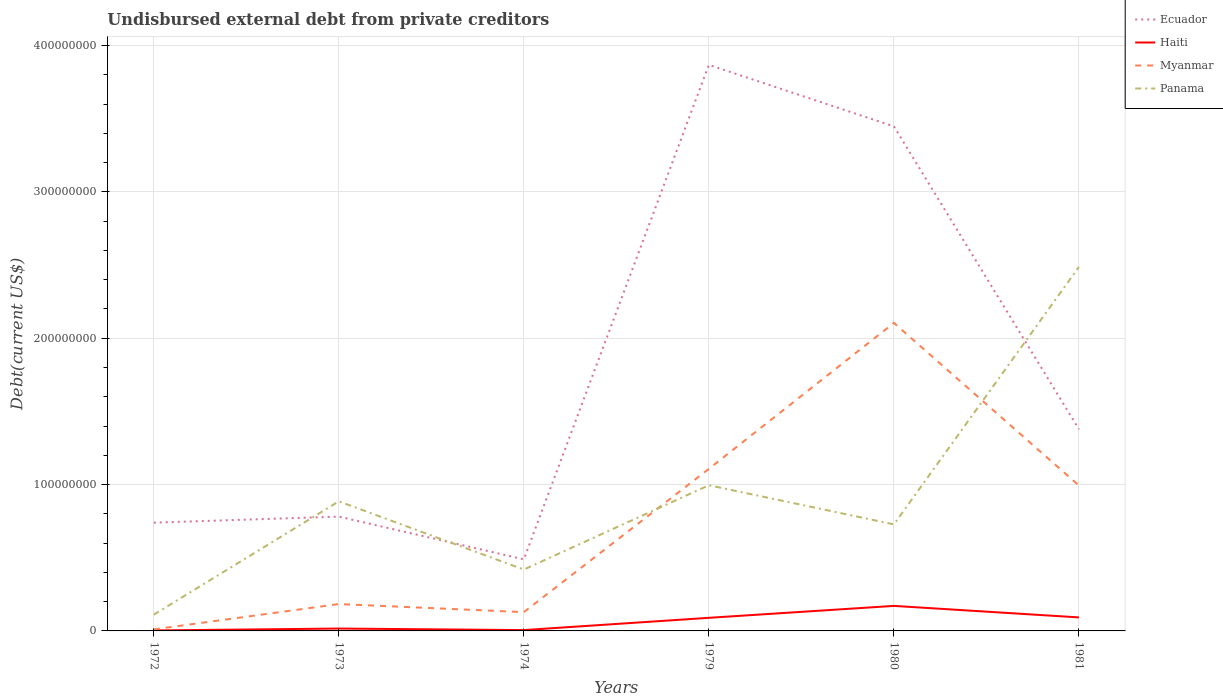How many different coloured lines are there?
Your response must be concise. 4. Across all years, what is the maximum total debt in Myanmar?
Ensure brevity in your answer.  1.05e+06. What is the total total debt in Panama in the graph?
Your response must be concise. -6.17e+07. What is the difference between the highest and the second highest total debt in Myanmar?
Ensure brevity in your answer.  2.09e+08. How many lines are there?
Your response must be concise. 4. How many years are there in the graph?
Ensure brevity in your answer.  6. Are the values on the major ticks of Y-axis written in scientific E-notation?
Keep it short and to the point. No. Does the graph contain grids?
Ensure brevity in your answer.  Yes. Where does the legend appear in the graph?
Provide a succinct answer. Top right. How are the legend labels stacked?
Provide a succinct answer. Vertical. What is the title of the graph?
Offer a very short reply. Undisbursed external debt from private creditors. What is the label or title of the Y-axis?
Make the answer very short. Debt(current US$). What is the Debt(current US$) of Ecuador in 1972?
Keep it short and to the point. 7.40e+07. What is the Debt(current US$) of Haiti in 1972?
Ensure brevity in your answer.  3.25e+05. What is the Debt(current US$) in Myanmar in 1972?
Offer a terse response. 1.05e+06. What is the Debt(current US$) of Panama in 1972?
Give a very brief answer. 1.11e+07. What is the Debt(current US$) of Ecuador in 1973?
Offer a very short reply. 7.81e+07. What is the Debt(current US$) in Haiti in 1973?
Keep it short and to the point. 1.62e+06. What is the Debt(current US$) of Myanmar in 1973?
Your answer should be very brief. 1.84e+07. What is the Debt(current US$) in Panama in 1973?
Give a very brief answer. 8.85e+07. What is the Debt(current US$) in Ecuador in 1974?
Give a very brief answer. 4.89e+07. What is the Debt(current US$) in Haiti in 1974?
Your response must be concise. 5.69e+05. What is the Debt(current US$) of Myanmar in 1974?
Your answer should be compact. 1.28e+07. What is the Debt(current US$) of Panama in 1974?
Your answer should be compact. 4.19e+07. What is the Debt(current US$) of Ecuador in 1979?
Make the answer very short. 3.87e+08. What is the Debt(current US$) in Haiti in 1979?
Your answer should be compact. 8.96e+06. What is the Debt(current US$) of Myanmar in 1979?
Make the answer very short. 1.11e+08. What is the Debt(current US$) of Panama in 1979?
Ensure brevity in your answer.  9.95e+07. What is the Debt(current US$) in Ecuador in 1980?
Provide a short and direct response. 3.45e+08. What is the Debt(current US$) in Haiti in 1980?
Ensure brevity in your answer.  1.71e+07. What is the Debt(current US$) of Myanmar in 1980?
Your answer should be compact. 2.10e+08. What is the Debt(current US$) in Panama in 1980?
Your response must be concise. 7.28e+07. What is the Debt(current US$) in Ecuador in 1981?
Offer a very short reply. 1.38e+08. What is the Debt(current US$) in Haiti in 1981?
Provide a short and direct response. 9.24e+06. What is the Debt(current US$) of Myanmar in 1981?
Your answer should be very brief. 9.93e+07. What is the Debt(current US$) of Panama in 1981?
Your answer should be compact. 2.49e+08. Across all years, what is the maximum Debt(current US$) of Ecuador?
Your response must be concise. 3.87e+08. Across all years, what is the maximum Debt(current US$) in Haiti?
Offer a terse response. 1.71e+07. Across all years, what is the maximum Debt(current US$) of Myanmar?
Provide a succinct answer. 2.10e+08. Across all years, what is the maximum Debt(current US$) in Panama?
Your answer should be very brief. 2.49e+08. Across all years, what is the minimum Debt(current US$) of Ecuador?
Ensure brevity in your answer.  4.89e+07. Across all years, what is the minimum Debt(current US$) in Haiti?
Offer a terse response. 3.25e+05. Across all years, what is the minimum Debt(current US$) in Myanmar?
Your answer should be compact. 1.05e+06. Across all years, what is the minimum Debt(current US$) in Panama?
Your answer should be very brief. 1.11e+07. What is the total Debt(current US$) in Ecuador in the graph?
Offer a terse response. 1.07e+09. What is the total Debt(current US$) in Haiti in the graph?
Provide a short and direct response. 3.78e+07. What is the total Debt(current US$) in Myanmar in the graph?
Keep it short and to the point. 4.53e+08. What is the total Debt(current US$) of Panama in the graph?
Give a very brief answer. 5.63e+08. What is the difference between the Debt(current US$) of Ecuador in 1972 and that in 1973?
Give a very brief answer. -4.14e+06. What is the difference between the Debt(current US$) in Haiti in 1972 and that in 1973?
Give a very brief answer. -1.30e+06. What is the difference between the Debt(current US$) of Myanmar in 1972 and that in 1973?
Offer a terse response. -1.73e+07. What is the difference between the Debt(current US$) of Panama in 1972 and that in 1973?
Ensure brevity in your answer.  -7.74e+07. What is the difference between the Debt(current US$) in Ecuador in 1972 and that in 1974?
Your answer should be very brief. 2.51e+07. What is the difference between the Debt(current US$) in Haiti in 1972 and that in 1974?
Your response must be concise. -2.44e+05. What is the difference between the Debt(current US$) of Myanmar in 1972 and that in 1974?
Your response must be concise. -1.18e+07. What is the difference between the Debt(current US$) of Panama in 1972 and that in 1974?
Offer a terse response. -3.08e+07. What is the difference between the Debt(current US$) of Ecuador in 1972 and that in 1979?
Provide a succinct answer. -3.13e+08. What is the difference between the Debt(current US$) in Haiti in 1972 and that in 1979?
Provide a short and direct response. -8.64e+06. What is the difference between the Debt(current US$) of Myanmar in 1972 and that in 1979?
Ensure brevity in your answer.  -1.10e+08. What is the difference between the Debt(current US$) in Panama in 1972 and that in 1979?
Give a very brief answer. -8.84e+07. What is the difference between the Debt(current US$) of Ecuador in 1972 and that in 1980?
Keep it short and to the point. -2.71e+08. What is the difference between the Debt(current US$) of Haiti in 1972 and that in 1980?
Provide a short and direct response. -1.68e+07. What is the difference between the Debt(current US$) of Myanmar in 1972 and that in 1980?
Your answer should be compact. -2.09e+08. What is the difference between the Debt(current US$) in Panama in 1972 and that in 1980?
Your answer should be compact. -6.17e+07. What is the difference between the Debt(current US$) in Ecuador in 1972 and that in 1981?
Keep it short and to the point. -6.38e+07. What is the difference between the Debt(current US$) in Haiti in 1972 and that in 1981?
Keep it short and to the point. -8.91e+06. What is the difference between the Debt(current US$) in Myanmar in 1972 and that in 1981?
Your answer should be compact. -9.83e+07. What is the difference between the Debt(current US$) in Panama in 1972 and that in 1981?
Provide a succinct answer. -2.38e+08. What is the difference between the Debt(current US$) of Ecuador in 1973 and that in 1974?
Provide a succinct answer. 2.92e+07. What is the difference between the Debt(current US$) of Haiti in 1973 and that in 1974?
Make the answer very short. 1.06e+06. What is the difference between the Debt(current US$) in Myanmar in 1973 and that in 1974?
Offer a very short reply. 5.53e+06. What is the difference between the Debt(current US$) in Panama in 1973 and that in 1974?
Your answer should be compact. 4.66e+07. What is the difference between the Debt(current US$) of Ecuador in 1973 and that in 1979?
Your response must be concise. -3.09e+08. What is the difference between the Debt(current US$) in Haiti in 1973 and that in 1979?
Keep it short and to the point. -7.34e+06. What is the difference between the Debt(current US$) in Myanmar in 1973 and that in 1979?
Your answer should be very brief. -9.24e+07. What is the difference between the Debt(current US$) of Panama in 1973 and that in 1979?
Your answer should be very brief. -1.10e+07. What is the difference between the Debt(current US$) in Ecuador in 1973 and that in 1980?
Your response must be concise. -2.67e+08. What is the difference between the Debt(current US$) of Haiti in 1973 and that in 1980?
Offer a very short reply. -1.55e+07. What is the difference between the Debt(current US$) in Myanmar in 1973 and that in 1980?
Your answer should be compact. -1.92e+08. What is the difference between the Debt(current US$) in Panama in 1973 and that in 1980?
Your answer should be very brief. 1.57e+07. What is the difference between the Debt(current US$) of Ecuador in 1973 and that in 1981?
Ensure brevity in your answer.  -5.97e+07. What is the difference between the Debt(current US$) in Haiti in 1973 and that in 1981?
Offer a very short reply. -7.61e+06. What is the difference between the Debt(current US$) in Myanmar in 1973 and that in 1981?
Keep it short and to the point. -8.10e+07. What is the difference between the Debt(current US$) of Panama in 1973 and that in 1981?
Your answer should be compact. -1.60e+08. What is the difference between the Debt(current US$) of Ecuador in 1974 and that in 1979?
Ensure brevity in your answer.  -3.38e+08. What is the difference between the Debt(current US$) in Haiti in 1974 and that in 1979?
Provide a succinct answer. -8.39e+06. What is the difference between the Debt(current US$) of Myanmar in 1974 and that in 1979?
Your answer should be compact. -9.79e+07. What is the difference between the Debt(current US$) in Panama in 1974 and that in 1979?
Your answer should be compact. -5.76e+07. What is the difference between the Debt(current US$) of Ecuador in 1974 and that in 1980?
Your answer should be compact. -2.96e+08. What is the difference between the Debt(current US$) of Haiti in 1974 and that in 1980?
Your answer should be compact. -1.65e+07. What is the difference between the Debt(current US$) of Myanmar in 1974 and that in 1980?
Your answer should be very brief. -1.98e+08. What is the difference between the Debt(current US$) of Panama in 1974 and that in 1980?
Your response must be concise. -3.09e+07. What is the difference between the Debt(current US$) of Ecuador in 1974 and that in 1981?
Ensure brevity in your answer.  -8.89e+07. What is the difference between the Debt(current US$) of Haiti in 1974 and that in 1981?
Your answer should be compact. -8.67e+06. What is the difference between the Debt(current US$) of Myanmar in 1974 and that in 1981?
Your answer should be very brief. -8.65e+07. What is the difference between the Debt(current US$) of Panama in 1974 and that in 1981?
Ensure brevity in your answer.  -2.07e+08. What is the difference between the Debt(current US$) in Ecuador in 1979 and that in 1980?
Your answer should be compact. 4.21e+07. What is the difference between the Debt(current US$) in Haiti in 1979 and that in 1980?
Ensure brevity in your answer.  -8.14e+06. What is the difference between the Debt(current US$) of Myanmar in 1979 and that in 1980?
Offer a very short reply. -9.97e+07. What is the difference between the Debt(current US$) in Panama in 1979 and that in 1980?
Your response must be concise. 2.67e+07. What is the difference between the Debt(current US$) of Ecuador in 1979 and that in 1981?
Provide a short and direct response. 2.49e+08. What is the difference between the Debt(current US$) of Haiti in 1979 and that in 1981?
Ensure brevity in your answer.  -2.78e+05. What is the difference between the Debt(current US$) in Myanmar in 1979 and that in 1981?
Keep it short and to the point. 1.14e+07. What is the difference between the Debt(current US$) of Panama in 1979 and that in 1981?
Give a very brief answer. -1.49e+08. What is the difference between the Debt(current US$) of Ecuador in 1980 and that in 1981?
Offer a terse response. 2.07e+08. What is the difference between the Debt(current US$) of Haiti in 1980 and that in 1981?
Provide a short and direct response. 7.87e+06. What is the difference between the Debt(current US$) in Myanmar in 1980 and that in 1981?
Ensure brevity in your answer.  1.11e+08. What is the difference between the Debt(current US$) in Panama in 1980 and that in 1981?
Your answer should be compact. -1.76e+08. What is the difference between the Debt(current US$) of Ecuador in 1972 and the Debt(current US$) of Haiti in 1973?
Provide a succinct answer. 7.24e+07. What is the difference between the Debt(current US$) of Ecuador in 1972 and the Debt(current US$) of Myanmar in 1973?
Give a very brief answer. 5.56e+07. What is the difference between the Debt(current US$) in Ecuador in 1972 and the Debt(current US$) in Panama in 1973?
Give a very brief answer. -1.46e+07. What is the difference between the Debt(current US$) in Haiti in 1972 and the Debt(current US$) in Myanmar in 1973?
Your answer should be compact. -1.80e+07. What is the difference between the Debt(current US$) of Haiti in 1972 and the Debt(current US$) of Panama in 1973?
Your response must be concise. -8.82e+07. What is the difference between the Debt(current US$) of Myanmar in 1972 and the Debt(current US$) of Panama in 1973?
Provide a short and direct response. -8.75e+07. What is the difference between the Debt(current US$) in Ecuador in 1972 and the Debt(current US$) in Haiti in 1974?
Provide a succinct answer. 7.34e+07. What is the difference between the Debt(current US$) in Ecuador in 1972 and the Debt(current US$) in Myanmar in 1974?
Offer a terse response. 6.11e+07. What is the difference between the Debt(current US$) in Ecuador in 1972 and the Debt(current US$) in Panama in 1974?
Your answer should be very brief. 3.20e+07. What is the difference between the Debt(current US$) of Haiti in 1972 and the Debt(current US$) of Myanmar in 1974?
Your answer should be compact. -1.25e+07. What is the difference between the Debt(current US$) in Haiti in 1972 and the Debt(current US$) in Panama in 1974?
Offer a very short reply. -4.16e+07. What is the difference between the Debt(current US$) in Myanmar in 1972 and the Debt(current US$) in Panama in 1974?
Provide a succinct answer. -4.09e+07. What is the difference between the Debt(current US$) in Ecuador in 1972 and the Debt(current US$) in Haiti in 1979?
Provide a short and direct response. 6.50e+07. What is the difference between the Debt(current US$) of Ecuador in 1972 and the Debt(current US$) of Myanmar in 1979?
Make the answer very short. -3.68e+07. What is the difference between the Debt(current US$) in Ecuador in 1972 and the Debt(current US$) in Panama in 1979?
Your answer should be very brief. -2.56e+07. What is the difference between the Debt(current US$) of Haiti in 1972 and the Debt(current US$) of Myanmar in 1979?
Offer a terse response. -1.10e+08. What is the difference between the Debt(current US$) of Haiti in 1972 and the Debt(current US$) of Panama in 1979?
Provide a succinct answer. -9.92e+07. What is the difference between the Debt(current US$) of Myanmar in 1972 and the Debt(current US$) of Panama in 1979?
Provide a short and direct response. -9.85e+07. What is the difference between the Debt(current US$) of Ecuador in 1972 and the Debt(current US$) of Haiti in 1980?
Your response must be concise. 5.69e+07. What is the difference between the Debt(current US$) in Ecuador in 1972 and the Debt(current US$) in Myanmar in 1980?
Make the answer very short. -1.36e+08. What is the difference between the Debt(current US$) in Ecuador in 1972 and the Debt(current US$) in Panama in 1980?
Your response must be concise. 1.17e+06. What is the difference between the Debt(current US$) in Haiti in 1972 and the Debt(current US$) in Myanmar in 1980?
Your answer should be very brief. -2.10e+08. What is the difference between the Debt(current US$) of Haiti in 1972 and the Debt(current US$) of Panama in 1980?
Offer a very short reply. -7.25e+07. What is the difference between the Debt(current US$) in Myanmar in 1972 and the Debt(current US$) in Panama in 1980?
Offer a terse response. -7.18e+07. What is the difference between the Debt(current US$) of Ecuador in 1972 and the Debt(current US$) of Haiti in 1981?
Your answer should be very brief. 6.47e+07. What is the difference between the Debt(current US$) of Ecuador in 1972 and the Debt(current US$) of Myanmar in 1981?
Make the answer very short. -2.54e+07. What is the difference between the Debt(current US$) of Ecuador in 1972 and the Debt(current US$) of Panama in 1981?
Keep it short and to the point. -1.75e+08. What is the difference between the Debt(current US$) of Haiti in 1972 and the Debt(current US$) of Myanmar in 1981?
Your response must be concise. -9.90e+07. What is the difference between the Debt(current US$) in Haiti in 1972 and the Debt(current US$) in Panama in 1981?
Give a very brief answer. -2.48e+08. What is the difference between the Debt(current US$) in Myanmar in 1972 and the Debt(current US$) in Panama in 1981?
Your answer should be very brief. -2.48e+08. What is the difference between the Debt(current US$) in Ecuador in 1973 and the Debt(current US$) in Haiti in 1974?
Make the answer very short. 7.75e+07. What is the difference between the Debt(current US$) of Ecuador in 1973 and the Debt(current US$) of Myanmar in 1974?
Give a very brief answer. 6.53e+07. What is the difference between the Debt(current US$) of Ecuador in 1973 and the Debt(current US$) of Panama in 1974?
Give a very brief answer. 3.62e+07. What is the difference between the Debt(current US$) of Haiti in 1973 and the Debt(current US$) of Myanmar in 1974?
Keep it short and to the point. -1.12e+07. What is the difference between the Debt(current US$) of Haiti in 1973 and the Debt(current US$) of Panama in 1974?
Provide a short and direct response. -4.03e+07. What is the difference between the Debt(current US$) in Myanmar in 1973 and the Debt(current US$) in Panama in 1974?
Offer a terse response. -2.36e+07. What is the difference between the Debt(current US$) in Ecuador in 1973 and the Debt(current US$) in Haiti in 1979?
Your response must be concise. 6.92e+07. What is the difference between the Debt(current US$) of Ecuador in 1973 and the Debt(current US$) of Myanmar in 1979?
Ensure brevity in your answer.  -3.26e+07. What is the difference between the Debt(current US$) of Ecuador in 1973 and the Debt(current US$) of Panama in 1979?
Provide a succinct answer. -2.14e+07. What is the difference between the Debt(current US$) of Haiti in 1973 and the Debt(current US$) of Myanmar in 1979?
Offer a very short reply. -1.09e+08. What is the difference between the Debt(current US$) of Haiti in 1973 and the Debt(current US$) of Panama in 1979?
Ensure brevity in your answer.  -9.79e+07. What is the difference between the Debt(current US$) in Myanmar in 1973 and the Debt(current US$) in Panama in 1979?
Your answer should be compact. -8.12e+07. What is the difference between the Debt(current US$) in Ecuador in 1973 and the Debt(current US$) in Haiti in 1980?
Provide a succinct answer. 6.10e+07. What is the difference between the Debt(current US$) in Ecuador in 1973 and the Debt(current US$) in Myanmar in 1980?
Ensure brevity in your answer.  -1.32e+08. What is the difference between the Debt(current US$) of Ecuador in 1973 and the Debt(current US$) of Panama in 1980?
Provide a succinct answer. 5.31e+06. What is the difference between the Debt(current US$) in Haiti in 1973 and the Debt(current US$) in Myanmar in 1980?
Keep it short and to the point. -2.09e+08. What is the difference between the Debt(current US$) in Haiti in 1973 and the Debt(current US$) in Panama in 1980?
Offer a very short reply. -7.12e+07. What is the difference between the Debt(current US$) of Myanmar in 1973 and the Debt(current US$) of Panama in 1980?
Make the answer very short. -5.44e+07. What is the difference between the Debt(current US$) of Ecuador in 1973 and the Debt(current US$) of Haiti in 1981?
Make the answer very short. 6.89e+07. What is the difference between the Debt(current US$) of Ecuador in 1973 and the Debt(current US$) of Myanmar in 1981?
Your response must be concise. -2.12e+07. What is the difference between the Debt(current US$) of Ecuador in 1973 and the Debt(current US$) of Panama in 1981?
Provide a succinct answer. -1.71e+08. What is the difference between the Debt(current US$) of Haiti in 1973 and the Debt(current US$) of Myanmar in 1981?
Offer a terse response. -9.77e+07. What is the difference between the Debt(current US$) of Haiti in 1973 and the Debt(current US$) of Panama in 1981?
Offer a very short reply. -2.47e+08. What is the difference between the Debt(current US$) of Myanmar in 1973 and the Debt(current US$) of Panama in 1981?
Ensure brevity in your answer.  -2.30e+08. What is the difference between the Debt(current US$) in Ecuador in 1974 and the Debt(current US$) in Haiti in 1979?
Provide a short and direct response. 4.00e+07. What is the difference between the Debt(current US$) of Ecuador in 1974 and the Debt(current US$) of Myanmar in 1979?
Provide a succinct answer. -6.18e+07. What is the difference between the Debt(current US$) in Ecuador in 1974 and the Debt(current US$) in Panama in 1979?
Make the answer very short. -5.06e+07. What is the difference between the Debt(current US$) of Haiti in 1974 and the Debt(current US$) of Myanmar in 1979?
Your answer should be very brief. -1.10e+08. What is the difference between the Debt(current US$) of Haiti in 1974 and the Debt(current US$) of Panama in 1979?
Offer a very short reply. -9.90e+07. What is the difference between the Debt(current US$) in Myanmar in 1974 and the Debt(current US$) in Panama in 1979?
Your answer should be compact. -8.67e+07. What is the difference between the Debt(current US$) in Ecuador in 1974 and the Debt(current US$) in Haiti in 1980?
Your answer should be compact. 3.18e+07. What is the difference between the Debt(current US$) in Ecuador in 1974 and the Debt(current US$) in Myanmar in 1980?
Your answer should be compact. -1.62e+08. What is the difference between the Debt(current US$) of Ecuador in 1974 and the Debt(current US$) of Panama in 1980?
Ensure brevity in your answer.  -2.39e+07. What is the difference between the Debt(current US$) in Haiti in 1974 and the Debt(current US$) in Myanmar in 1980?
Provide a short and direct response. -2.10e+08. What is the difference between the Debt(current US$) in Haiti in 1974 and the Debt(current US$) in Panama in 1980?
Offer a terse response. -7.22e+07. What is the difference between the Debt(current US$) in Myanmar in 1974 and the Debt(current US$) in Panama in 1980?
Provide a succinct answer. -6.00e+07. What is the difference between the Debt(current US$) in Ecuador in 1974 and the Debt(current US$) in Haiti in 1981?
Offer a very short reply. 3.97e+07. What is the difference between the Debt(current US$) of Ecuador in 1974 and the Debt(current US$) of Myanmar in 1981?
Your answer should be very brief. -5.04e+07. What is the difference between the Debt(current US$) of Ecuador in 1974 and the Debt(current US$) of Panama in 1981?
Offer a terse response. -2.00e+08. What is the difference between the Debt(current US$) in Haiti in 1974 and the Debt(current US$) in Myanmar in 1981?
Your answer should be very brief. -9.88e+07. What is the difference between the Debt(current US$) of Haiti in 1974 and the Debt(current US$) of Panama in 1981?
Give a very brief answer. -2.48e+08. What is the difference between the Debt(current US$) of Myanmar in 1974 and the Debt(current US$) of Panama in 1981?
Your answer should be very brief. -2.36e+08. What is the difference between the Debt(current US$) of Ecuador in 1979 and the Debt(current US$) of Haiti in 1980?
Your answer should be very brief. 3.70e+08. What is the difference between the Debt(current US$) in Ecuador in 1979 and the Debt(current US$) in Myanmar in 1980?
Offer a terse response. 1.76e+08. What is the difference between the Debt(current US$) of Ecuador in 1979 and the Debt(current US$) of Panama in 1980?
Provide a short and direct response. 3.14e+08. What is the difference between the Debt(current US$) in Haiti in 1979 and the Debt(current US$) in Myanmar in 1980?
Your answer should be compact. -2.02e+08. What is the difference between the Debt(current US$) in Haiti in 1979 and the Debt(current US$) in Panama in 1980?
Your response must be concise. -6.38e+07. What is the difference between the Debt(current US$) of Myanmar in 1979 and the Debt(current US$) of Panama in 1980?
Make the answer very short. 3.79e+07. What is the difference between the Debt(current US$) in Ecuador in 1979 and the Debt(current US$) in Haiti in 1981?
Give a very brief answer. 3.78e+08. What is the difference between the Debt(current US$) in Ecuador in 1979 and the Debt(current US$) in Myanmar in 1981?
Offer a very short reply. 2.87e+08. What is the difference between the Debt(current US$) in Ecuador in 1979 and the Debt(current US$) in Panama in 1981?
Your answer should be very brief. 1.38e+08. What is the difference between the Debt(current US$) in Haiti in 1979 and the Debt(current US$) in Myanmar in 1981?
Your answer should be compact. -9.04e+07. What is the difference between the Debt(current US$) in Haiti in 1979 and the Debt(current US$) in Panama in 1981?
Your response must be concise. -2.40e+08. What is the difference between the Debt(current US$) of Myanmar in 1979 and the Debt(current US$) of Panama in 1981?
Your answer should be compact. -1.38e+08. What is the difference between the Debt(current US$) in Ecuador in 1980 and the Debt(current US$) in Haiti in 1981?
Provide a short and direct response. 3.35e+08. What is the difference between the Debt(current US$) of Ecuador in 1980 and the Debt(current US$) of Myanmar in 1981?
Give a very brief answer. 2.45e+08. What is the difference between the Debt(current US$) of Ecuador in 1980 and the Debt(current US$) of Panama in 1981?
Your answer should be compact. 9.60e+07. What is the difference between the Debt(current US$) of Haiti in 1980 and the Debt(current US$) of Myanmar in 1981?
Your answer should be very brief. -8.22e+07. What is the difference between the Debt(current US$) in Haiti in 1980 and the Debt(current US$) in Panama in 1981?
Provide a succinct answer. -2.32e+08. What is the difference between the Debt(current US$) of Myanmar in 1980 and the Debt(current US$) of Panama in 1981?
Offer a terse response. -3.83e+07. What is the average Debt(current US$) of Ecuador per year?
Ensure brevity in your answer.  1.78e+08. What is the average Debt(current US$) in Haiti per year?
Your answer should be compact. 6.30e+06. What is the average Debt(current US$) of Myanmar per year?
Provide a short and direct response. 7.55e+07. What is the average Debt(current US$) in Panama per year?
Offer a terse response. 9.38e+07. In the year 1972, what is the difference between the Debt(current US$) of Ecuador and Debt(current US$) of Haiti?
Provide a succinct answer. 7.36e+07. In the year 1972, what is the difference between the Debt(current US$) of Ecuador and Debt(current US$) of Myanmar?
Offer a very short reply. 7.29e+07. In the year 1972, what is the difference between the Debt(current US$) in Ecuador and Debt(current US$) in Panama?
Make the answer very short. 6.29e+07. In the year 1972, what is the difference between the Debt(current US$) in Haiti and Debt(current US$) in Myanmar?
Keep it short and to the point. -7.26e+05. In the year 1972, what is the difference between the Debt(current US$) of Haiti and Debt(current US$) of Panama?
Offer a very short reply. -1.08e+07. In the year 1972, what is the difference between the Debt(current US$) of Myanmar and Debt(current US$) of Panama?
Provide a succinct answer. -1.01e+07. In the year 1973, what is the difference between the Debt(current US$) in Ecuador and Debt(current US$) in Haiti?
Your answer should be compact. 7.65e+07. In the year 1973, what is the difference between the Debt(current US$) of Ecuador and Debt(current US$) of Myanmar?
Offer a very short reply. 5.98e+07. In the year 1973, what is the difference between the Debt(current US$) of Ecuador and Debt(current US$) of Panama?
Your response must be concise. -1.04e+07. In the year 1973, what is the difference between the Debt(current US$) in Haiti and Debt(current US$) in Myanmar?
Offer a terse response. -1.67e+07. In the year 1973, what is the difference between the Debt(current US$) in Haiti and Debt(current US$) in Panama?
Your answer should be compact. -8.69e+07. In the year 1973, what is the difference between the Debt(current US$) of Myanmar and Debt(current US$) of Panama?
Your answer should be compact. -7.02e+07. In the year 1974, what is the difference between the Debt(current US$) in Ecuador and Debt(current US$) in Haiti?
Ensure brevity in your answer.  4.83e+07. In the year 1974, what is the difference between the Debt(current US$) of Ecuador and Debt(current US$) of Myanmar?
Offer a very short reply. 3.61e+07. In the year 1974, what is the difference between the Debt(current US$) in Ecuador and Debt(current US$) in Panama?
Offer a terse response. 6.98e+06. In the year 1974, what is the difference between the Debt(current US$) in Haiti and Debt(current US$) in Myanmar?
Offer a very short reply. -1.23e+07. In the year 1974, what is the difference between the Debt(current US$) in Haiti and Debt(current US$) in Panama?
Your response must be concise. -4.14e+07. In the year 1974, what is the difference between the Debt(current US$) in Myanmar and Debt(current US$) in Panama?
Provide a short and direct response. -2.91e+07. In the year 1979, what is the difference between the Debt(current US$) in Ecuador and Debt(current US$) in Haiti?
Provide a succinct answer. 3.78e+08. In the year 1979, what is the difference between the Debt(current US$) of Ecuador and Debt(current US$) of Myanmar?
Your response must be concise. 2.76e+08. In the year 1979, what is the difference between the Debt(current US$) of Ecuador and Debt(current US$) of Panama?
Make the answer very short. 2.87e+08. In the year 1979, what is the difference between the Debt(current US$) of Haiti and Debt(current US$) of Myanmar?
Offer a terse response. -1.02e+08. In the year 1979, what is the difference between the Debt(current US$) in Haiti and Debt(current US$) in Panama?
Provide a succinct answer. -9.06e+07. In the year 1979, what is the difference between the Debt(current US$) of Myanmar and Debt(current US$) of Panama?
Offer a very short reply. 1.12e+07. In the year 1980, what is the difference between the Debt(current US$) in Ecuador and Debt(current US$) in Haiti?
Your response must be concise. 3.28e+08. In the year 1980, what is the difference between the Debt(current US$) of Ecuador and Debt(current US$) of Myanmar?
Provide a short and direct response. 1.34e+08. In the year 1980, what is the difference between the Debt(current US$) in Ecuador and Debt(current US$) in Panama?
Provide a succinct answer. 2.72e+08. In the year 1980, what is the difference between the Debt(current US$) of Haiti and Debt(current US$) of Myanmar?
Offer a very short reply. -1.93e+08. In the year 1980, what is the difference between the Debt(current US$) in Haiti and Debt(current US$) in Panama?
Provide a succinct answer. -5.57e+07. In the year 1980, what is the difference between the Debt(current US$) in Myanmar and Debt(current US$) in Panama?
Provide a succinct answer. 1.38e+08. In the year 1981, what is the difference between the Debt(current US$) in Ecuador and Debt(current US$) in Haiti?
Offer a terse response. 1.29e+08. In the year 1981, what is the difference between the Debt(current US$) in Ecuador and Debt(current US$) in Myanmar?
Your answer should be compact. 3.85e+07. In the year 1981, what is the difference between the Debt(current US$) in Ecuador and Debt(current US$) in Panama?
Your answer should be very brief. -1.11e+08. In the year 1981, what is the difference between the Debt(current US$) in Haiti and Debt(current US$) in Myanmar?
Provide a short and direct response. -9.01e+07. In the year 1981, what is the difference between the Debt(current US$) of Haiti and Debt(current US$) of Panama?
Offer a terse response. -2.39e+08. In the year 1981, what is the difference between the Debt(current US$) of Myanmar and Debt(current US$) of Panama?
Make the answer very short. -1.49e+08. What is the ratio of the Debt(current US$) of Ecuador in 1972 to that in 1973?
Your answer should be compact. 0.95. What is the ratio of the Debt(current US$) of Myanmar in 1972 to that in 1973?
Ensure brevity in your answer.  0.06. What is the ratio of the Debt(current US$) of Panama in 1972 to that in 1973?
Make the answer very short. 0.13. What is the ratio of the Debt(current US$) in Ecuador in 1972 to that in 1974?
Provide a succinct answer. 1.51. What is the ratio of the Debt(current US$) in Haiti in 1972 to that in 1974?
Make the answer very short. 0.57. What is the ratio of the Debt(current US$) of Myanmar in 1972 to that in 1974?
Offer a terse response. 0.08. What is the ratio of the Debt(current US$) in Panama in 1972 to that in 1974?
Offer a very short reply. 0.27. What is the ratio of the Debt(current US$) in Ecuador in 1972 to that in 1979?
Your answer should be very brief. 0.19. What is the ratio of the Debt(current US$) of Haiti in 1972 to that in 1979?
Ensure brevity in your answer.  0.04. What is the ratio of the Debt(current US$) in Myanmar in 1972 to that in 1979?
Ensure brevity in your answer.  0.01. What is the ratio of the Debt(current US$) in Panama in 1972 to that in 1979?
Offer a terse response. 0.11. What is the ratio of the Debt(current US$) of Ecuador in 1972 to that in 1980?
Keep it short and to the point. 0.21. What is the ratio of the Debt(current US$) in Haiti in 1972 to that in 1980?
Ensure brevity in your answer.  0.02. What is the ratio of the Debt(current US$) in Myanmar in 1972 to that in 1980?
Offer a terse response. 0.01. What is the ratio of the Debt(current US$) in Panama in 1972 to that in 1980?
Ensure brevity in your answer.  0.15. What is the ratio of the Debt(current US$) in Ecuador in 1972 to that in 1981?
Keep it short and to the point. 0.54. What is the ratio of the Debt(current US$) of Haiti in 1972 to that in 1981?
Your response must be concise. 0.04. What is the ratio of the Debt(current US$) of Myanmar in 1972 to that in 1981?
Ensure brevity in your answer.  0.01. What is the ratio of the Debt(current US$) in Panama in 1972 to that in 1981?
Ensure brevity in your answer.  0.04. What is the ratio of the Debt(current US$) of Ecuador in 1973 to that in 1974?
Your answer should be compact. 1.6. What is the ratio of the Debt(current US$) in Haiti in 1973 to that in 1974?
Provide a short and direct response. 2.86. What is the ratio of the Debt(current US$) in Myanmar in 1973 to that in 1974?
Give a very brief answer. 1.43. What is the ratio of the Debt(current US$) in Panama in 1973 to that in 1974?
Give a very brief answer. 2.11. What is the ratio of the Debt(current US$) of Ecuador in 1973 to that in 1979?
Offer a very short reply. 0.2. What is the ratio of the Debt(current US$) in Haiti in 1973 to that in 1979?
Your response must be concise. 0.18. What is the ratio of the Debt(current US$) in Myanmar in 1973 to that in 1979?
Offer a terse response. 0.17. What is the ratio of the Debt(current US$) in Panama in 1973 to that in 1979?
Provide a succinct answer. 0.89. What is the ratio of the Debt(current US$) of Ecuador in 1973 to that in 1980?
Give a very brief answer. 0.23. What is the ratio of the Debt(current US$) in Haiti in 1973 to that in 1980?
Your answer should be compact. 0.1. What is the ratio of the Debt(current US$) in Myanmar in 1973 to that in 1980?
Your answer should be very brief. 0.09. What is the ratio of the Debt(current US$) in Panama in 1973 to that in 1980?
Offer a very short reply. 1.22. What is the ratio of the Debt(current US$) of Ecuador in 1973 to that in 1981?
Your answer should be very brief. 0.57. What is the ratio of the Debt(current US$) in Haiti in 1973 to that in 1981?
Your answer should be very brief. 0.18. What is the ratio of the Debt(current US$) in Myanmar in 1973 to that in 1981?
Your response must be concise. 0.18. What is the ratio of the Debt(current US$) of Panama in 1973 to that in 1981?
Ensure brevity in your answer.  0.36. What is the ratio of the Debt(current US$) of Ecuador in 1974 to that in 1979?
Your answer should be very brief. 0.13. What is the ratio of the Debt(current US$) of Haiti in 1974 to that in 1979?
Provide a succinct answer. 0.06. What is the ratio of the Debt(current US$) in Myanmar in 1974 to that in 1979?
Ensure brevity in your answer.  0.12. What is the ratio of the Debt(current US$) of Panama in 1974 to that in 1979?
Make the answer very short. 0.42. What is the ratio of the Debt(current US$) in Ecuador in 1974 to that in 1980?
Provide a short and direct response. 0.14. What is the ratio of the Debt(current US$) of Haiti in 1974 to that in 1980?
Provide a short and direct response. 0.03. What is the ratio of the Debt(current US$) of Myanmar in 1974 to that in 1980?
Give a very brief answer. 0.06. What is the ratio of the Debt(current US$) in Panama in 1974 to that in 1980?
Offer a very short reply. 0.58. What is the ratio of the Debt(current US$) in Ecuador in 1974 to that in 1981?
Give a very brief answer. 0.35. What is the ratio of the Debt(current US$) of Haiti in 1974 to that in 1981?
Make the answer very short. 0.06. What is the ratio of the Debt(current US$) of Myanmar in 1974 to that in 1981?
Your answer should be compact. 0.13. What is the ratio of the Debt(current US$) of Panama in 1974 to that in 1981?
Your answer should be very brief. 0.17. What is the ratio of the Debt(current US$) of Ecuador in 1979 to that in 1980?
Keep it short and to the point. 1.12. What is the ratio of the Debt(current US$) in Haiti in 1979 to that in 1980?
Make the answer very short. 0.52. What is the ratio of the Debt(current US$) in Myanmar in 1979 to that in 1980?
Make the answer very short. 0.53. What is the ratio of the Debt(current US$) of Panama in 1979 to that in 1980?
Provide a succinct answer. 1.37. What is the ratio of the Debt(current US$) in Ecuador in 1979 to that in 1981?
Give a very brief answer. 2.81. What is the ratio of the Debt(current US$) in Haiti in 1979 to that in 1981?
Give a very brief answer. 0.97. What is the ratio of the Debt(current US$) of Myanmar in 1979 to that in 1981?
Ensure brevity in your answer.  1.11. What is the ratio of the Debt(current US$) in Panama in 1979 to that in 1981?
Keep it short and to the point. 0.4. What is the ratio of the Debt(current US$) of Ecuador in 1980 to that in 1981?
Provide a short and direct response. 2.5. What is the ratio of the Debt(current US$) in Haiti in 1980 to that in 1981?
Give a very brief answer. 1.85. What is the ratio of the Debt(current US$) in Myanmar in 1980 to that in 1981?
Offer a terse response. 2.12. What is the ratio of the Debt(current US$) of Panama in 1980 to that in 1981?
Your answer should be very brief. 0.29. What is the difference between the highest and the second highest Debt(current US$) of Ecuador?
Ensure brevity in your answer.  4.21e+07. What is the difference between the highest and the second highest Debt(current US$) in Haiti?
Your answer should be compact. 7.87e+06. What is the difference between the highest and the second highest Debt(current US$) of Myanmar?
Your answer should be very brief. 9.97e+07. What is the difference between the highest and the second highest Debt(current US$) in Panama?
Keep it short and to the point. 1.49e+08. What is the difference between the highest and the lowest Debt(current US$) in Ecuador?
Your answer should be very brief. 3.38e+08. What is the difference between the highest and the lowest Debt(current US$) in Haiti?
Offer a terse response. 1.68e+07. What is the difference between the highest and the lowest Debt(current US$) in Myanmar?
Ensure brevity in your answer.  2.09e+08. What is the difference between the highest and the lowest Debt(current US$) of Panama?
Offer a very short reply. 2.38e+08. 